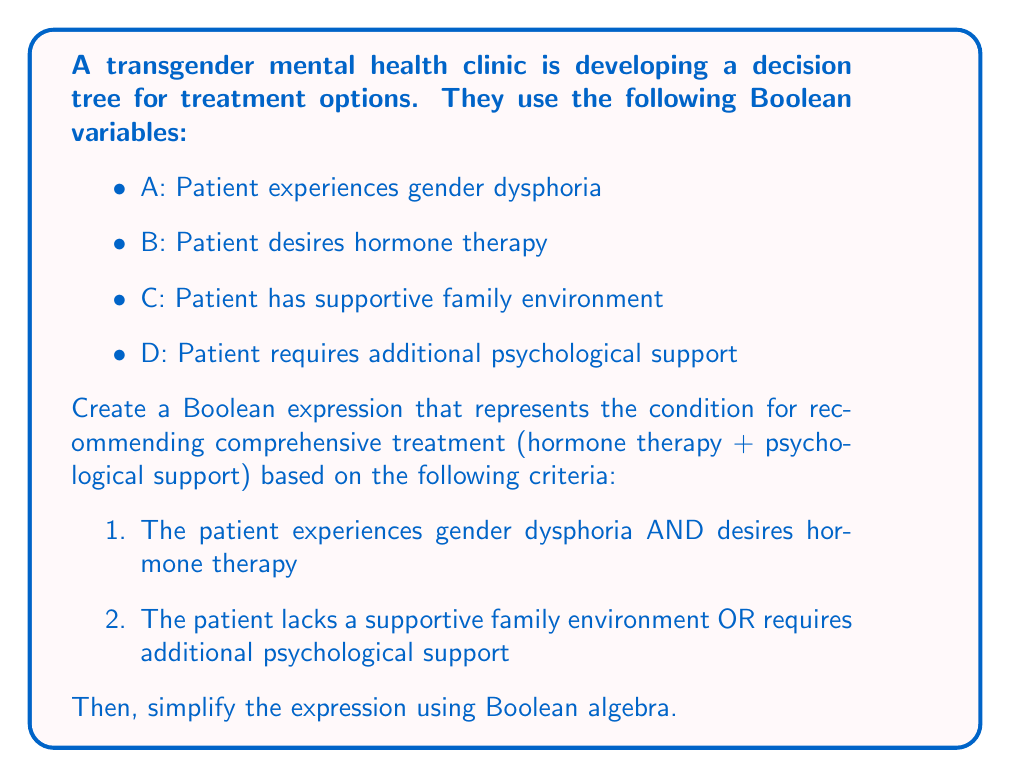Teach me how to tackle this problem. Let's approach this step-by-step:

1. First, we'll create the Boolean expression based on the given criteria:

   Comprehensive Treatment = (A AND B) AND (NOT C OR D)

2. We can represent this using Boolean algebra symbols:

   $$(A \wedge B) \wedge (\neg C \vee D)$$

3. To simplify this expression, we'll use the distributive law of Boolean algebra:

   $$(A \wedge B) \wedge \neg C \vee (A \wedge B) \wedge D$$

4. Now, we can apply the associative law:

   $$A \wedge B \wedge \neg C \vee A \wedge B \wedge D$$

5. This expression is already in its simplest form, known as the disjunctive normal form (DNF).

6. We can interpret this result as follows:
   Comprehensive treatment is recommended if:
   - The patient experiences gender dysphoria AND desires hormone therapy AND lacks a supportive family environment
   OR
   - The patient experiences gender dysphoria AND desires hormone therapy AND requires additional psychological support

This decision tree helps ensure that transgender individuals receive appropriate and comprehensive mental health support tailored to their specific needs and circumstances.
Answer: $$A \wedge B \wedge \neg C \vee A \wedge B \wedge D$$ 